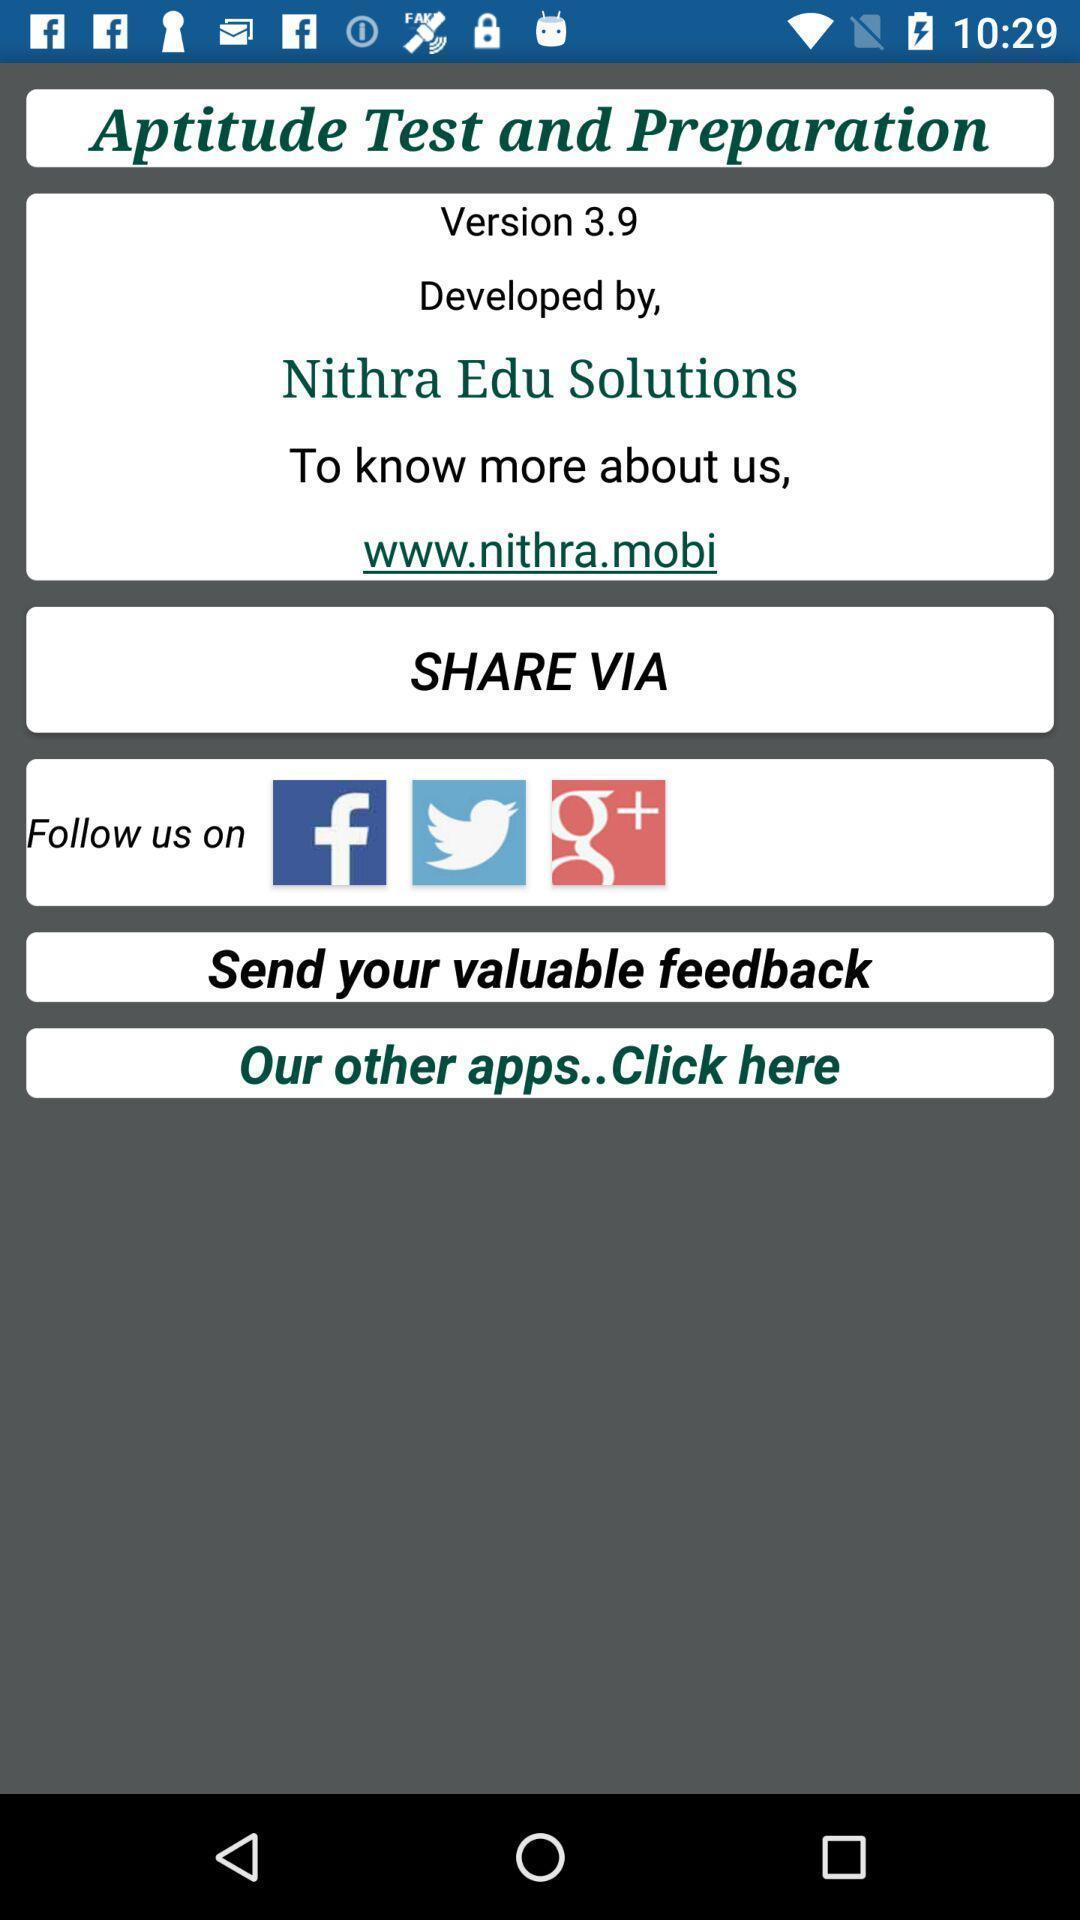What is the overall content of this screenshot? Screen displaying the page of an education app. 